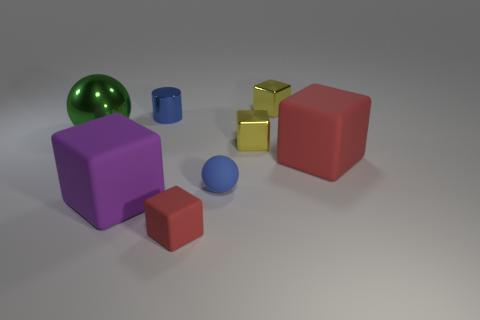There is a matte cube that is right of the small red rubber object; is its size the same as the blue object left of the tiny blue matte sphere?
Your answer should be compact. No. Is the number of big rubber objects greater than the number of tiny red objects?
Provide a succinct answer. Yes. What number of yellow things are made of the same material as the tiny blue cylinder?
Your answer should be compact. 2. Is the big shiny object the same shape as the purple thing?
Provide a short and direct response. No. There is a red matte object that is right of the small yellow object in front of the tiny shiny block that is behind the big green ball; what is its size?
Your answer should be very brief. Large. There is a small yellow metallic block behind the big metallic thing; are there any cubes in front of it?
Ensure brevity in your answer.  Yes. There is a matte block that is on the left side of the small cube in front of the large purple object; how many big red rubber objects are in front of it?
Provide a short and direct response. 0. There is a tiny object that is on the left side of the tiny sphere and in front of the big green metallic sphere; what color is it?
Your response must be concise. Red. What number of small objects are the same color as the matte ball?
Offer a terse response. 1. What number of blocks are big blue rubber things or purple matte objects?
Give a very brief answer. 1. 